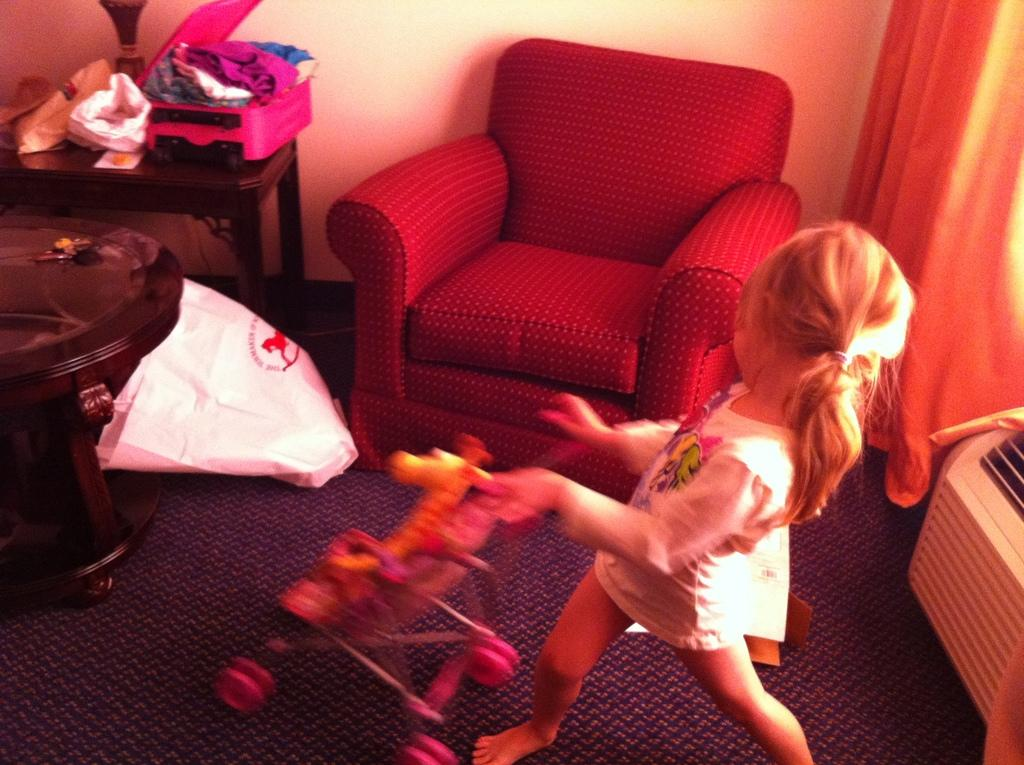Who is the main subject in the image? There is a small girl in the image. What is the girl doing in the image? The girl is playing with a toy. What type of furniture is present in the image? There is a sofa in the image. What type of window treatment is present in the image? There is a curtain in the image. What type of trail can be seen behind the girl in the image? There is no trail visible behind the girl in the image. 